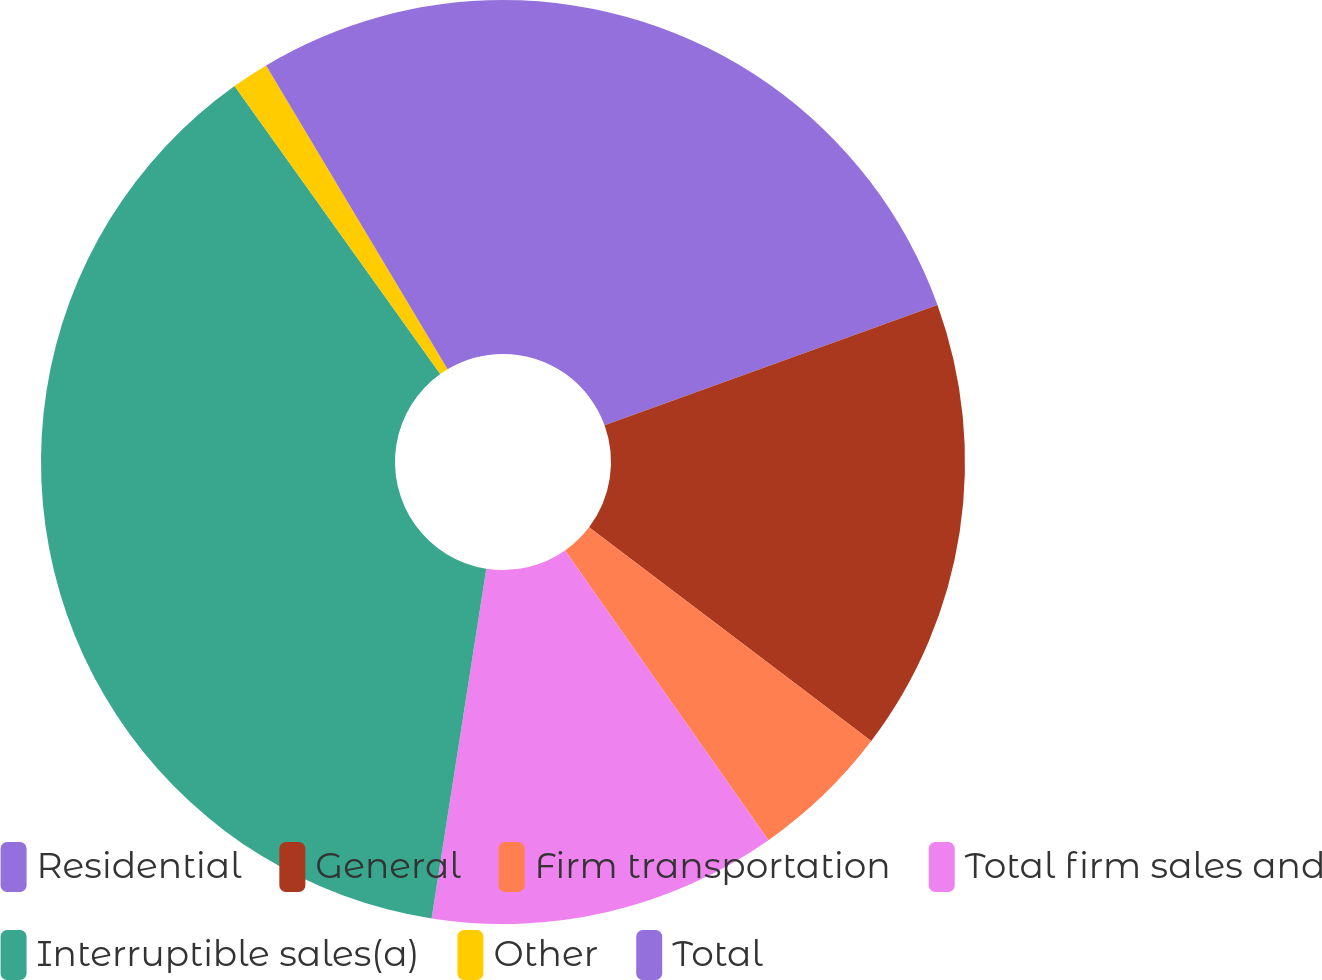Convert chart. <chart><loc_0><loc_0><loc_500><loc_500><pie_chart><fcel>Residential<fcel>General<fcel>Firm transportation<fcel>Total firm sales and<fcel>Interruptible sales(a)<fcel>Other<fcel>Total<nl><fcel>19.48%<fcel>15.84%<fcel>4.94%<fcel>12.21%<fcel>37.66%<fcel>1.3%<fcel>8.57%<nl></chart> 